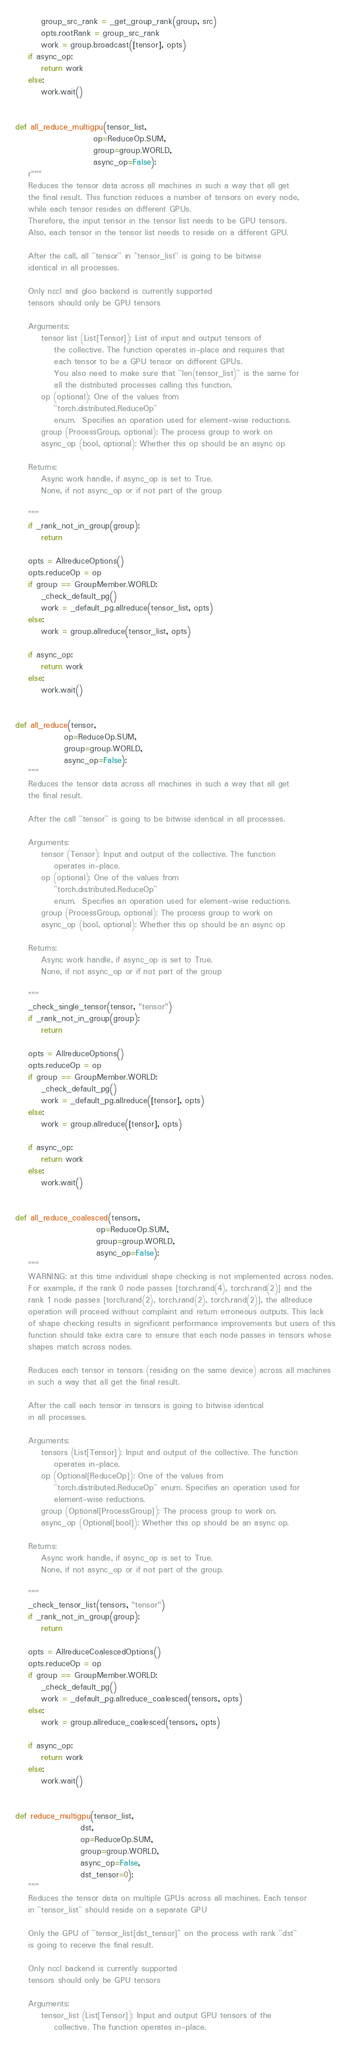Convert code to text. <code><loc_0><loc_0><loc_500><loc_500><_Python_>        group_src_rank = _get_group_rank(group, src)
        opts.rootRank = group_src_rank
        work = group.broadcast([tensor], opts)
    if async_op:
        return work
    else:
        work.wait()


def all_reduce_multigpu(tensor_list,
                        op=ReduceOp.SUM,
                        group=group.WORLD,
                        async_op=False):
    r"""
    Reduces the tensor data across all machines in such a way that all get
    the final result. This function reduces a number of tensors on every node,
    while each tensor resides on different GPUs.
    Therefore, the input tensor in the tensor list needs to be GPU tensors.
    Also, each tensor in the tensor list needs to reside on a different GPU.

    After the call, all ``tensor`` in ``tensor_list`` is going to be bitwise
    identical in all processes.

    Only nccl and gloo backend is currently supported
    tensors should only be GPU tensors

    Arguments:
        tensor list (List[Tensor]): List of input and output tensors of
            the collective. The function operates in-place and requires that
            each tensor to be a GPU tensor on different GPUs.
            You also need to make sure that ``len(tensor_list)`` is the same for
            all the distributed processes calling this function.
        op (optional): One of the values from
            ``torch.distributed.ReduceOp``
            enum.  Specifies an operation used for element-wise reductions.
        group (ProcessGroup, optional): The process group to work on
        async_op (bool, optional): Whether this op should be an async op

    Returns:
        Async work handle, if async_op is set to True.
        None, if not async_op or if not part of the group

    """
    if _rank_not_in_group(group):
        return

    opts = AllreduceOptions()
    opts.reduceOp = op
    if group == GroupMember.WORLD:
        _check_default_pg()
        work = _default_pg.allreduce(tensor_list, opts)
    else:
        work = group.allreduce(tensor_list, opts)

    if async_op:
        return work
    else:
        work.wait()


def all_reduce(tensor,
               op=ReduceOp.SUM,
               group=group.WORLD,
               async_op=False):
    """
    Reduces the tensor data across all machines in such a way that all get
    the final result.

    After the call ``tensor`` is going to be bitwise identical in all processes.

    Arguments:
        tensor (Tensor): Input and output of the collective. The function
            operates in-place.
        op (optional): One of the values from
            ``torch.distributed.ReduceOp``
            enum.  Specifies an operation used for element-wise reductions.
        group (ProcessGroup, optional): The process group to work on
        async_op (bool, optional): Whether this op should be an async op

    Returns:
        Async work handle, if async_op is set to True.
        None, if not async_op or if not part of the group

    """
    _check_single_tensor(tensor, "tensor")
    if _rank_not_in_group(group):
        return

    opts = AllreduceOptions()
    opts.reduceOp = op
    if group == GroupMember.WORLD:
        _check_default_pg()
        work = _default_pg.allreduce([tensor], opts)
    else:
        work = group.allreduce([tensor], opts)

    if async_op:
        return work
    else:
        work.wait()


def all_reduce_coalesced(tensors,
                         op=ReduceOp.SUM,
                         group=group.WORLD,
                         async_op=False):
    """
    WARNING: at this time individual shape checking is not implemented across nodes.
    For example, if the rank 0 node passes [torch.rand(4), torch.rand(2)] and the
    rank 1 node passes [torch.rand(2), torch.rand(2), torch.rand(2)], the allreduce
    operation will proceed without complaint and return erroneous outputs. This lack
    of shape checking results in significant performance improvements but users of this
    function should take extra care to ensure that each node passes in tensors whose
    shapes match across nodes.

    Reduces each tensor in tensors (residing on the same device) across all machines
    in such a way that all get the final result.

    After the call each tensor in tensors is going to bitwise identical
    in all processes.

    Arguments:
        tensors (List[Tensor]): Input and output of the collective. The function
            operates in-place.
        op (Optional[ReduceOp]): One of the values from
            ``torch.distributed.ReduceOp`` enum. Specifies an operation used for
            element-wise reductions.
        group (Optional[ProcessGroup]): The process group to work on.
        async_op (Optional[bool]): Whether this op should be an async op.

    Returns:
        Async work handle, if async_op is set to True.
        None, if not async_op or if not part of the group.

    """
    _check_tensor_list(tensors, "tensor")
    if _rank_not_in_group(group):
        return

    opts = AllreduceCoalescedOptions()
    opts.reduceOp = op
    if group == GroupMember.WORLD:
        _check_default_pg()
        work = _default_pg.allreduce_coalesced(tensors, opts)
    else:
        work = group.allreduce_coalesced(tensors, opts)

    if async_op:
        return work
    else:
        work.wait()


def reduce_multigpu(tensor_list,
                    dst,
                    op=ReduceOp.SUM,
                    group=group.WORLD,
                    async_op=False,
                    dst_tensor=0):
    """
    Reduces the tensor data on multiple GPUs across all machines. Each tensor
    in ``tensor_list`` should reside on a separate GPU

    Only the GPU of ``tensor_list[dst_tensor]`` on the process with rank ``dst``
    is going to receive the final result.

    Only nccl backend is currently supported
    tensors should only be GPU tensors

    Arguments:
        tensor_list (List[Tensor]): Input and output GPU tensors of the
            collective. The function operates in-place.</code> 